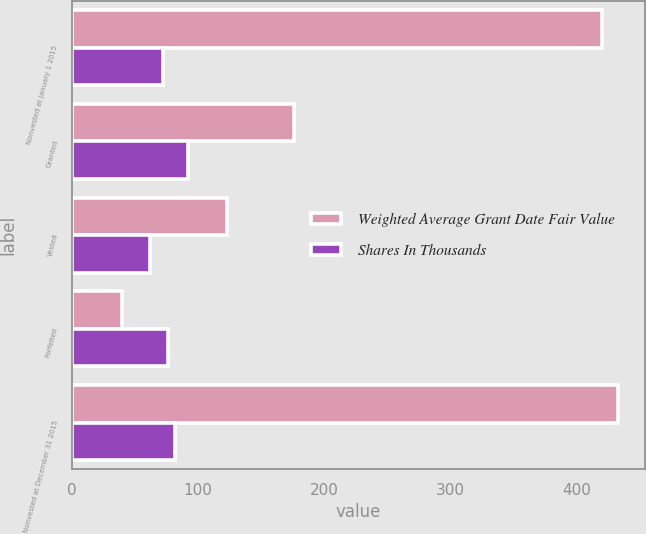Convert chart. <chart><loc_0><loc_0><loc_500><loc_500><stacked_bar_chart><ecel><fcel>Nonvested at January 1 2015<fcel>Granted<fcel>Vested<fcel>Forfeited<fcel>Nonvested at December 31 2015<nl><fcel>Weighted Average Grant Date Fair Value<fcel>420<fcel>176<fcel>123<fcel>40<fcel>433<nl><fcel>Shares In Thousands<fcel>72<fcel>92<fcel>62<fcel>76<fcel>82<nl></chart> 